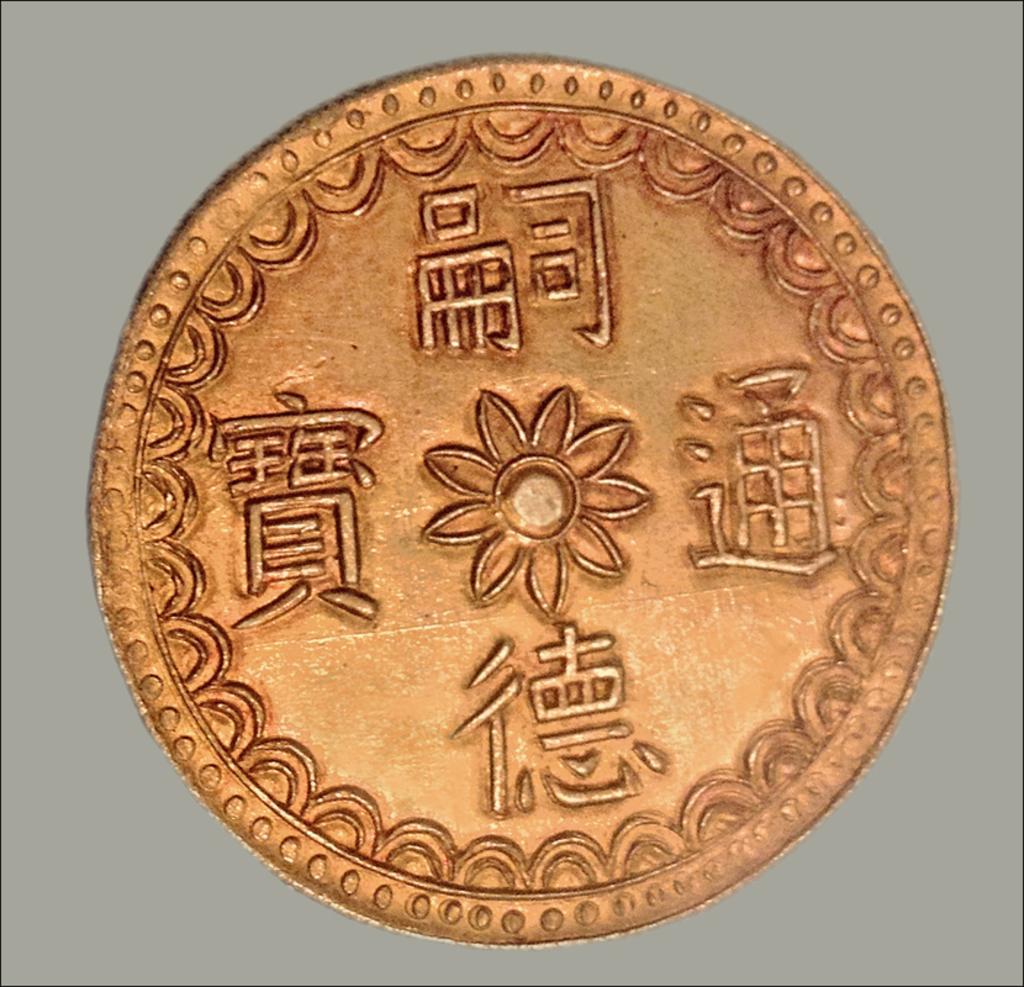How would you summarize this image in a sentence or two? In this picture I can see a coin and a plain background. 